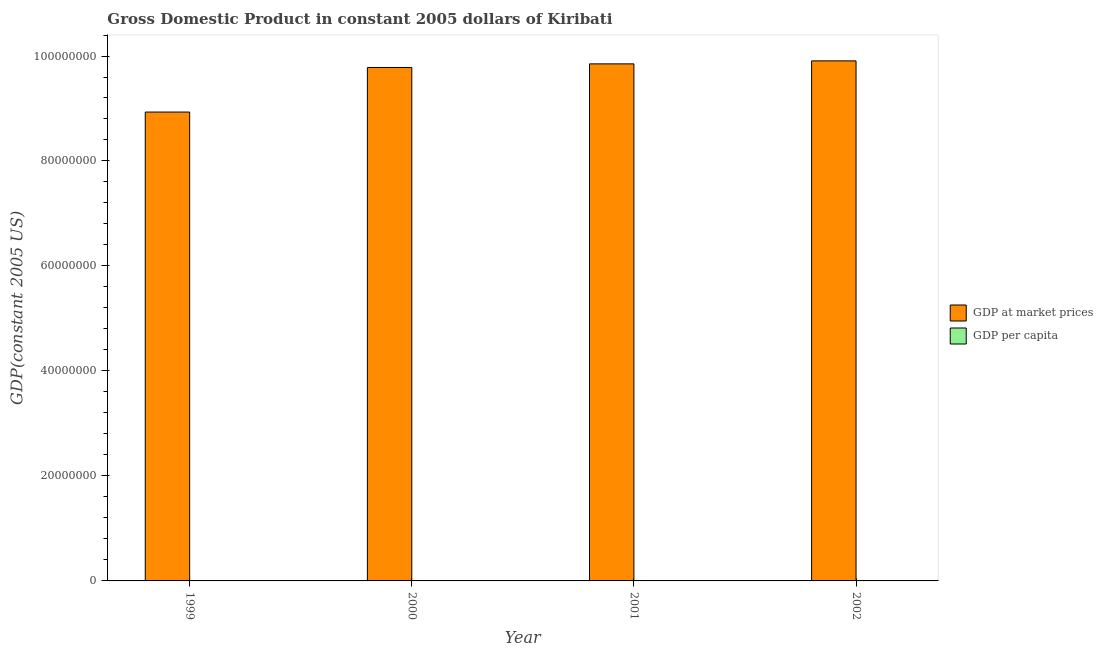How many different coloured bars are there?
Keep it short and to the point. 2. How many groups of bars are there?
Your response must be concise. 4. How many bars are there on the 1st tick from the right?
Provide a short and direct response. 2. In how many cases, is the number of bars for a given year not equal to the number of legend labels?
Your answer should be very brief. 0. What is the gdp per capita in 2000?
Provide a short and direct response. 1158.87. Across all years, what is the maximum gdp per capita?
Offer a terse response. 1158.87. Across all years, what is the minimum gdp per capita?
Give a very brief answer. 1076.59. In which year was the gdp at market prices minimum?
Your answer should be very brief. 1999. What is the total gdp per capita in the graph?
Provide a short and direct response. 4517.02. What is the difference between the gdp per capita in 2000 and that in 2001?
Offer a terse response. 11.59. What is the difference between the gdp at market prices in 2001 and the gdp per capita in 1999?
Ensure brevity in your answer.  9.18e+06. What is the average gdp at market prices per year?
Your answer should be compact. 9.62e+07. In the year 2001, what is the difference between the gdp at market prices and gdp per capita?
Offer a very short reply. 0. What is the ratio of the gdp at market prices in 1999 to that in 2002?
Offer a terse response. 0.9. Is the gdp at market prices in 1999 less than that in 2000?
Keep it short and to the point. Yes. What is the difference between the highest and the second highest gdp per capita?
Provide a succinct answer. 11.59. What is the difference between the highest and the lowest gdp per capita?
Keep it short and to the point. 82.28. What does the 1st bar from the left in 2000 represents?
Keep it short and to the point. GDP at market prices. What does the 2nd bar from the right in 2000 represents?
Make the answer very short. GDP at market prices. Are all the bars in the graph horizontal?
Your response must be concise. No. How many years are there in the graph?
Offer a very short reply. 4. Are the values on the major ticks of Y-axis written in scientific E-notation?
Offer a very short reply. No. Does the graph contain grids?
Offer a terse response. No. How many legend labels are there?
Your answer should be very brief. 2. What is the title of the graph?
Offer a terse response. Gross Domestic Product in constant 2005 dollars of Kiribati. Does "Commercial service imports" appear as one of the legend labels in the graph?
Keep it short and to the point. No. What is the label or title of the Y-axis?
Offer a very short reply. GDP(constant 2005 US). What is the GDP(constant 2005 US) in GDP at market prices in 1999?
Make the answer very short. 8.93e+07. What is the GDP(constant 2005 US) of GDP per capita in 1999?
Offer a very short reply. 1076.59. What is the GDP(constant 2005 US) in GDP at market prices in 2000?
Offer a terse response. 9.78e+07. What is the GDP(constant 2005 US) of GDP per capita in 2000?
Your response must be concise. 1158.87. What is the GDP(constant 2005 US) in GDP at market prices in 2001?
Keep it short and to the point. 9.85e+07. What is the GDP(constant 2005 US) of GDP per capita in 2001?
Your response must be concise. 1147.28. What is the GDP(constant 2005 US) of GDP at market prices in 2002?
Make the answer very short. 9.91e+07. What is the GDP(constant 2005 US) of GDP per capita in 2002?
Give a very brief answer. 1134.29. Across all years, what is the maximum GDP(constant 2005 US) of GDP at market prices?
Offer a terse response. 9.91e+07. Across all years, what is the maximum GDP(constant 2005 US) of GDP per capita?
Give a very brief answer. 1158.87. Across all years, what is the minimum GDP(constant 2005 US) in GDP at market prices?
Your answer should be compact. 8.93e+07. Across all years, what is the minimum GDP(constant 2005 US) of GDP per capita?
Provide a short and direct response. 1076.59. What is the total GDP(constant 2005 US) of GDP at market prices in the graph?
Your answer should be compact. 3.85e+08. What is the total GDP(constant 2005 US) of GDP per capita in the graph?
Your answer should be very brief. 4517.02. What is the difference between the GDP(constant 2005 US) in GDP at market prices in 1999 and that in 2000?
Offer a terse response. -8.49e+06. What is the difference between the GDP(constant 2005 US) of GDP per capita in 1999 and that in 2000?
Make the answer very short. -82.28. What is the difference between the GDP(constant 2005 US) of GDP at market prices in 1999 and that in 2001?
Ensure brevity in your answer.  -9.18e+06. What is the difference between the GDP(constant 2005 US) of GDP per capita in 1999 and that in 2001?
Ensure brevity in your answer.  -70.69. What is the difference between the GDP(constant 2005 US) of GDP at market prices in 1999 and that in 2002?
Your answer should be compact. -9.75e+06. What is the difference between the GDP(constant 2005 US) of GDP per capita in 1999 and that in 2002?
Your response must be concise. -57.7. What is the difference between the GDP(constant 2005 US) of GDP at market prices in 2000 and that in 2001?
Ensure brevity in your answer.  -6.88e+05. What is the difference between the GDP(constant 2005 US) of GDP per capita in 2000 and that in 2001?
Your answer should be very brief. 11.59. What is the difference between the GDP(constant 2005 US) of GDP at market prices in 2000 and that in 2002?
Give a very brief answer. -1.26e+06. What is the difference between the GDP(constant 2005 US) of GDP per capita in 2000 and that in 2002?
Provide a succinct answer. 24.58. What is the difference between the GDP(constant 2005 US) in GDP at market prices in 2001 and that in 2002?
Provide a succinct answer. -5.69e+05. What is the difference between the GDP(constant 2005 US) in GDP per capita in 2001 and that in 2002?
Your response must be concise. 12.99. What is the difference between the GDP(constant 2005 US) of GDP at market prices in 1999 and the GDP(constant 2005 US) of GDP per capita in 2000?
Provide a succinct answer. 8.93e+07. What is the difference between the GDP(constant 2005 US) in GDP at market prices in 1999 and the GDP(constant 2005 US) in GDP per capita in 2001?
Offer a terse response. 8.93e+07. What is the difference between the GDP(constant 2005 US) of GDP at market prices in 1999 and the GDP(constant 2005 US) of GDP per capita in 2002?
Make the answer very short. 8.93e+07. What is the difference between the GDP(constant 2005 US) of GDP at market prices in 2000 and the GDP(constant 2005 US) of GDP per capita in 2001?
Give a very brief answer. 9.78e+07. What is the difference between the GDP(constant 2005 US) in GDP at market prices in 2000 and the GDP(constant 2005 US) in GDP per capita in 2002?
Offer a very short reply. 9.78e+07. What is the difference between the GDP(constant 2005 US) of GDP at market prices in 2001 and the GDP(constant 2005 US) of GDP per capita in 2002?
Offer a very short reply. 9.85e+07. What is the average GDP(constant 2005 US) of GDP at market prices per year?
Offer a terse response. 9.62e+07. What is the average GDP(constant 2005 US) of GDP per capita per year?
Offer a very short reply. 1129.26. In the year 1999, what is the difference between the GDP(constant 2005 US) in GDP at market prices and GDP(constant 2005 US) in GDP per capita?
Your answer should be compact. 8.93e+07. In the year 2000, what is the difference between the GDP(constant 2005 US) of GDP at market prices and GDP(constant 2005 US) of GDP per capita?
Provide a succinct answer. 9.78e+07. In the year 2001, what is the difference between the GDP(constant 2005 US) of GDP at market prices and GDP(constant 2005 US) of GDP per capita?
Make the answer very short. 9.85e+07. In the year 2002, what is the difference between the GDP(constant 2005 US) in GDP at market prices and GDP(constant 2005 US) in GDP per capita?
Make the answer very short. 9.91e+07. What is the ratio of the GDP(constant 2005 US) of GDP at market prices in 1999 to that in 2000?
Offer a terse response. 0.91. What is the ratio of the GDP(constant 2005 US) of GDP per capita in 1999 to that in 2000?
Ensure brevity in your answer.  0.93. What is the ratio of the GDP(constant 2005 US) in GDP at market prices in 1999 to that in 2001?
Your answer should be compact. 0.91. What is the ratio of the GDP(constant 2005 US) of GDP per capita in 1999 to that in 2001?
Your answer should be very brief. 0.94. What is the ratio of the GDP(constant 2005 US) of GDP at market prices in 1999 to that in 2002?
Offer a very short reply. 0.9. What is the ratio of the GDP(constant 2005 US) of GDP per capita in 1999 to that in 2002?
Ensure brevity in your answer.  0.95. What is the ratio of the GDP(constant 2005 US) in GDP at market prices in 2000 to that in 2001?
Ensure brevity in your answer.  0.99. What is the ratio of the GDP(constant 2005 US) in GDP at market prices in 2000 to that in 2002?
Your answer should be very brief. 0.99. What is the ratio of the GDP(constant 2005 US) in GDP per capita in 2000 to that in 2002?
Provide a succinct answer. 1.02. What is the ratio of the GDP(constant 2005 US) of GDP per capita in 2001 to that in 2002?
Give a very brief answer. 1.01. What is the difference between the highest and the second highest GDP(constant 2005 US) of GDP at market prices?
Your response must be concise. 5.69e+05. What is the difference between the highest and the second highest GDP(constant 2005 US) in GDP per capita?
Your answer should be compact. 11.59. What is the difference between the highest and the lowest GDP(constant 2005 US) in GDP at market prices?
Make the answer very short. 9.75e+06. What is the difference between the highest and the lowest GDP(constant 2005 US) in GDP per capita?
Your answer should be very brief. 82.28. 